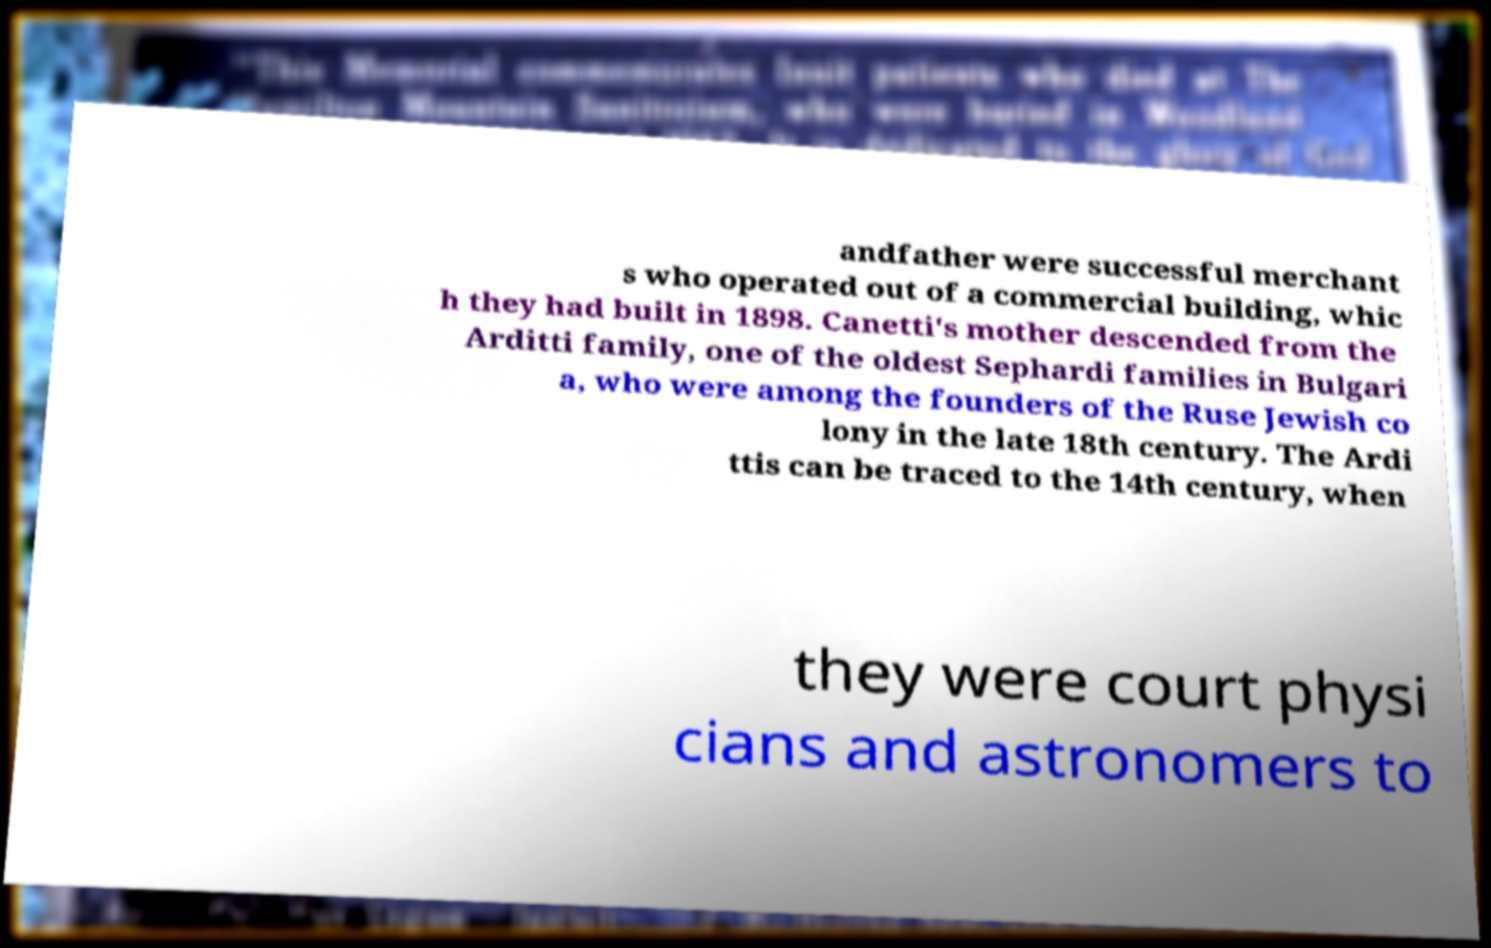Could you assist in decoding the text presented in this image and type it out clearly? andfather were successful merchant s who operated out of a commercial building, whic h they had built in 1898. Canetti's mother descended from the Arditti family, one of the oldest Sephardi families in Bulgari a, who were among the founders of the Ruse Jewish co lony in the late 18th century. The Ardi ttis can be traced to the 14th century, when they were court physi cians and astronomers to 